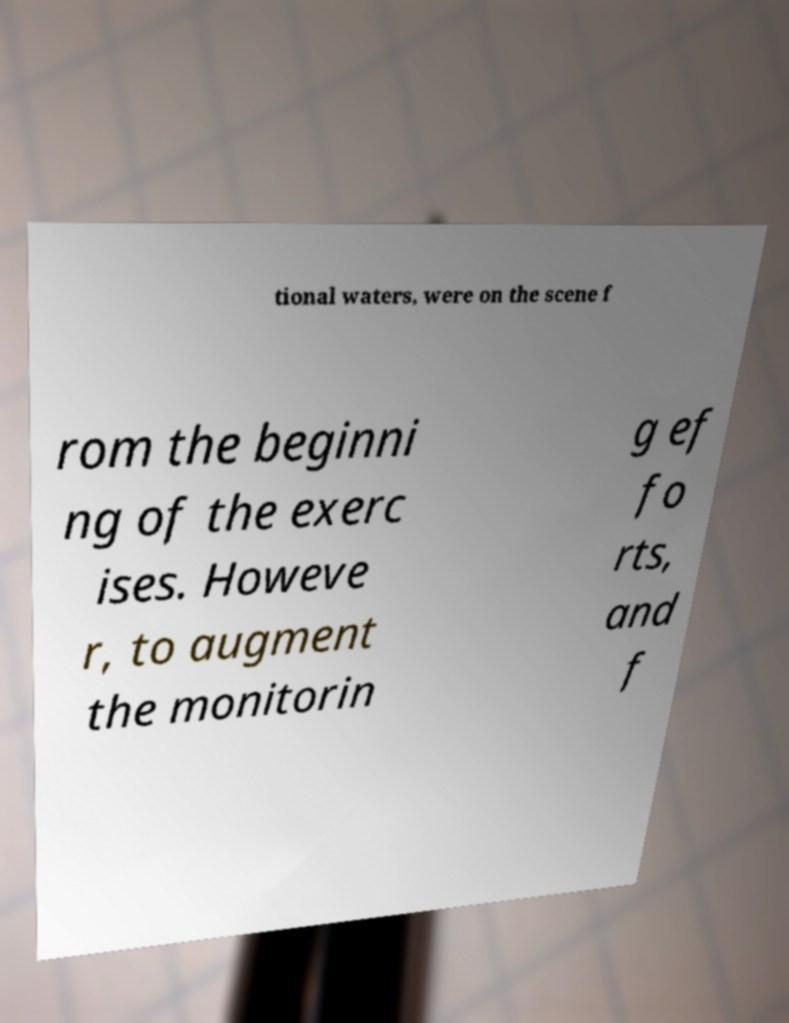For documentation purposes, I need the text within this image transcribed. Could you provide that? tional waters, were on the scene f rom the beginni ng of the exerc ises. Howeve r, to augment the monitorin g ef fo rts, and f 